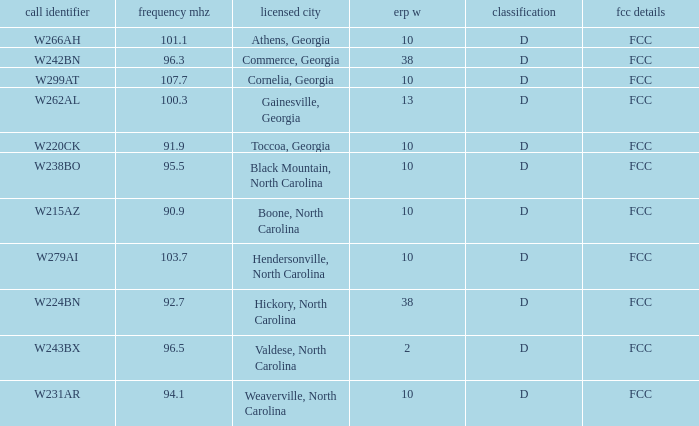What is the FCC frequency for the station w262al which has a Frequency MHz larger than 92.7? FCC. 